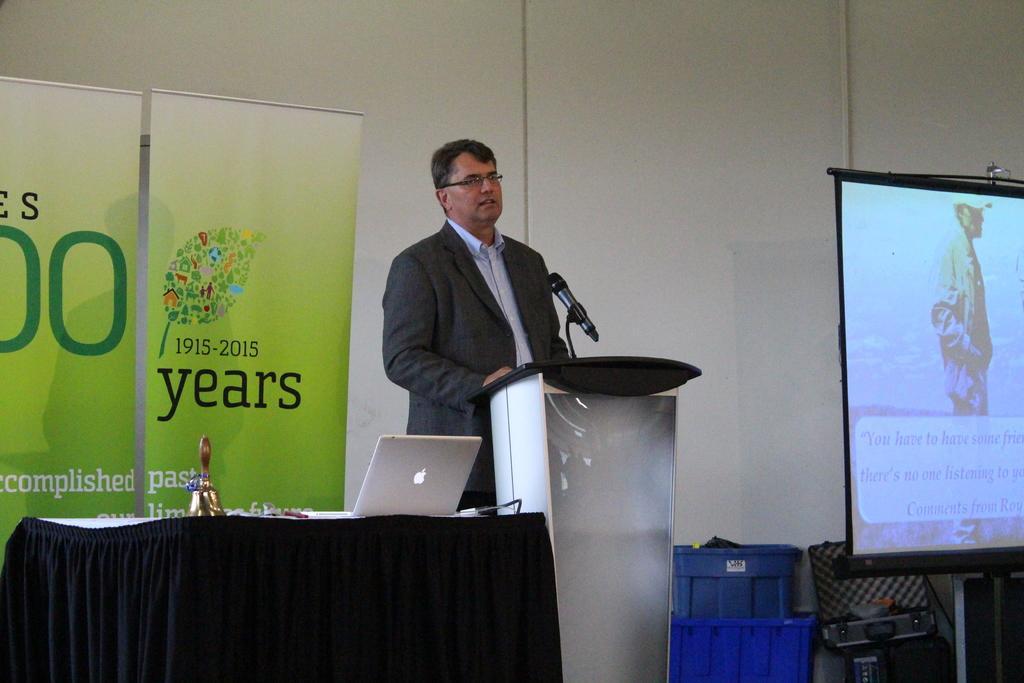Could you give a brief overview of what you see in this image? In this image there is a person standing in front of the dais. On top of the days there is a mike. On the left side of the image there is a table. On top of it there is a laptop and a few other objects. There are banners. In the background of the image there is a wall. On the right side of the image there is a screen. Beside the screen there are baskets and a few other objects. 